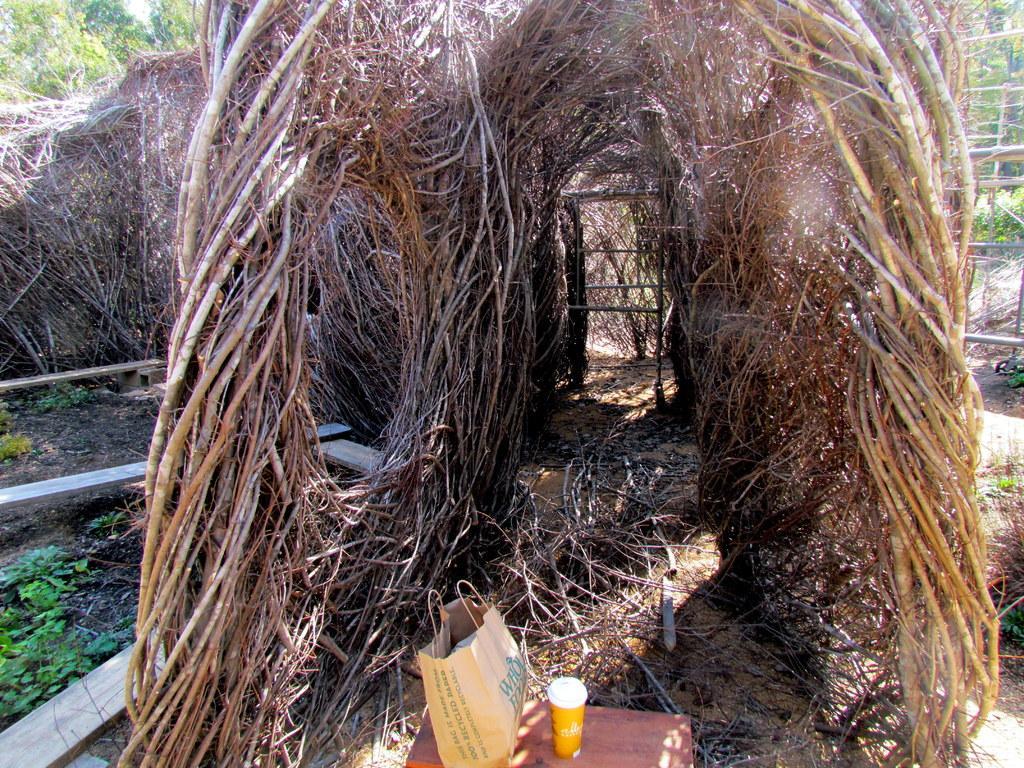Could you give a brief overview of what you see in this image? There is a shed made with stems made with stems and roots. In the front there is a table. On that there is a cover and a cup. On the left side there are plants and some woods. In the back there are trees. 